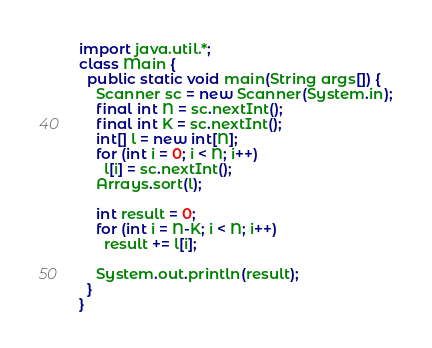<code> <loc_0><loc_0><loc_500><loc_500><_Java_>import java.util.*;
class Main {
  public static void main(String args[]) {
    Scanner sc = new Scanner(System.in);
    final int N = sc.nextInt();
    final int K = sc.nextInt();
    int[] l = new int[N];
    for (int i = 0; i < N; i++)
      l[i] = sc.nextInt();
    Arrays.sort(l);

    int result = 0;
    for (int i = N-K; i < N; i++)
      result += l[i];

    System.out.println(result);
  }
}</code> 